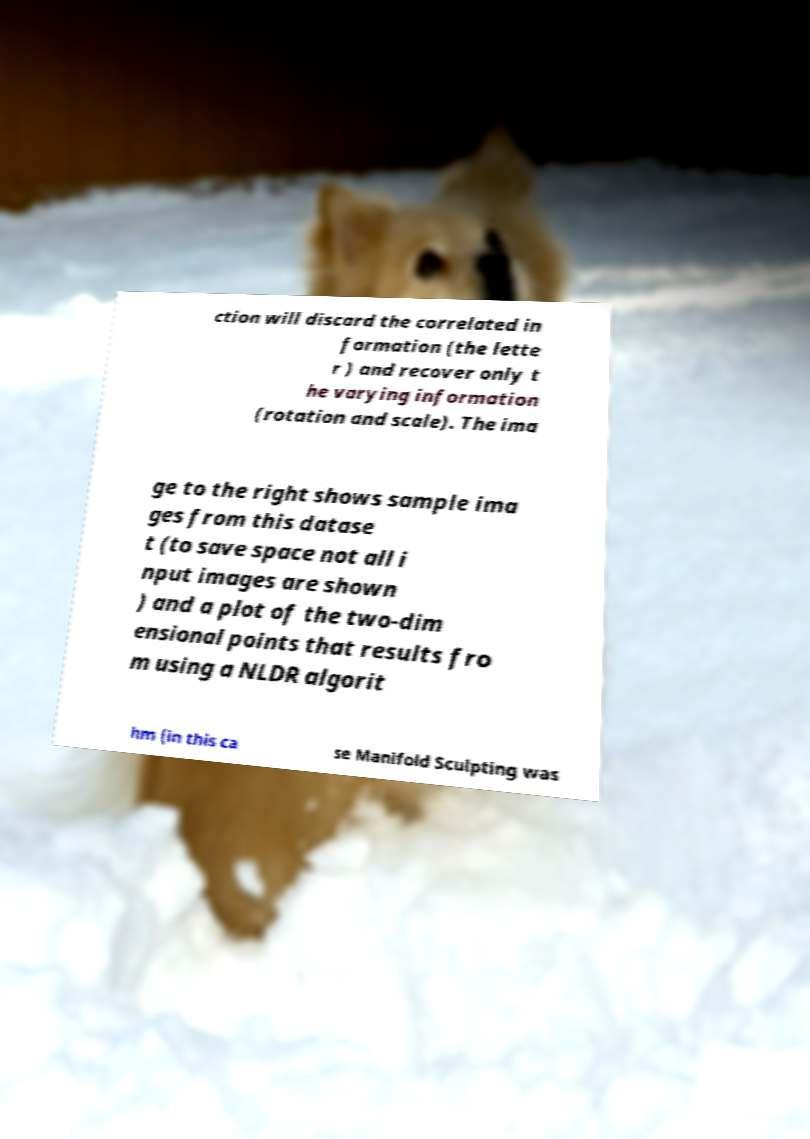Can you accurately transcribe the text from the provided image for me? ction will discard the correlated in formation (the lette r ) and recover only t he varying information (rotation and scale). The ima ge to the right shows sample ima ges from this datase t (to save space not all i nput images are shown ) and a plot of the two-dim ensional points that results fro m using a NLDR algorit hm (in this ca se Manifold Sculpting was 